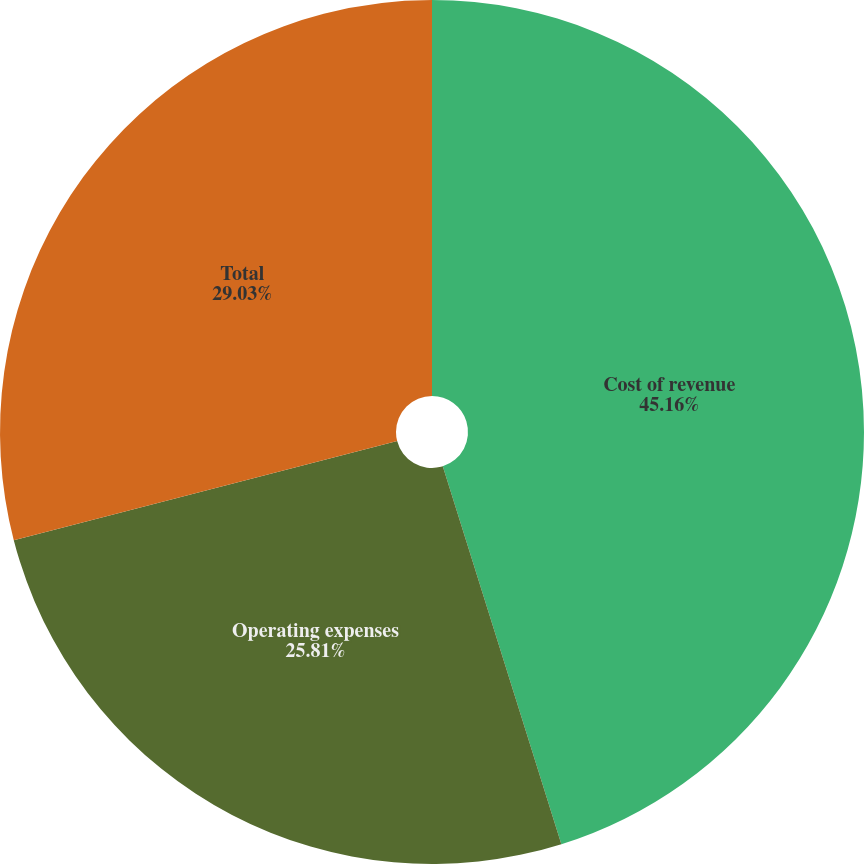Convert chart to OTSL. <chart><loc_0><loc_0><loc_500><loc_500><pie_chart><fcel>Cost of revenue<fcel>Operating expenses<fcel>Total<nl><fcel>45.16%<fcel>25.81%<fcel>29.03%<nl></chart> 